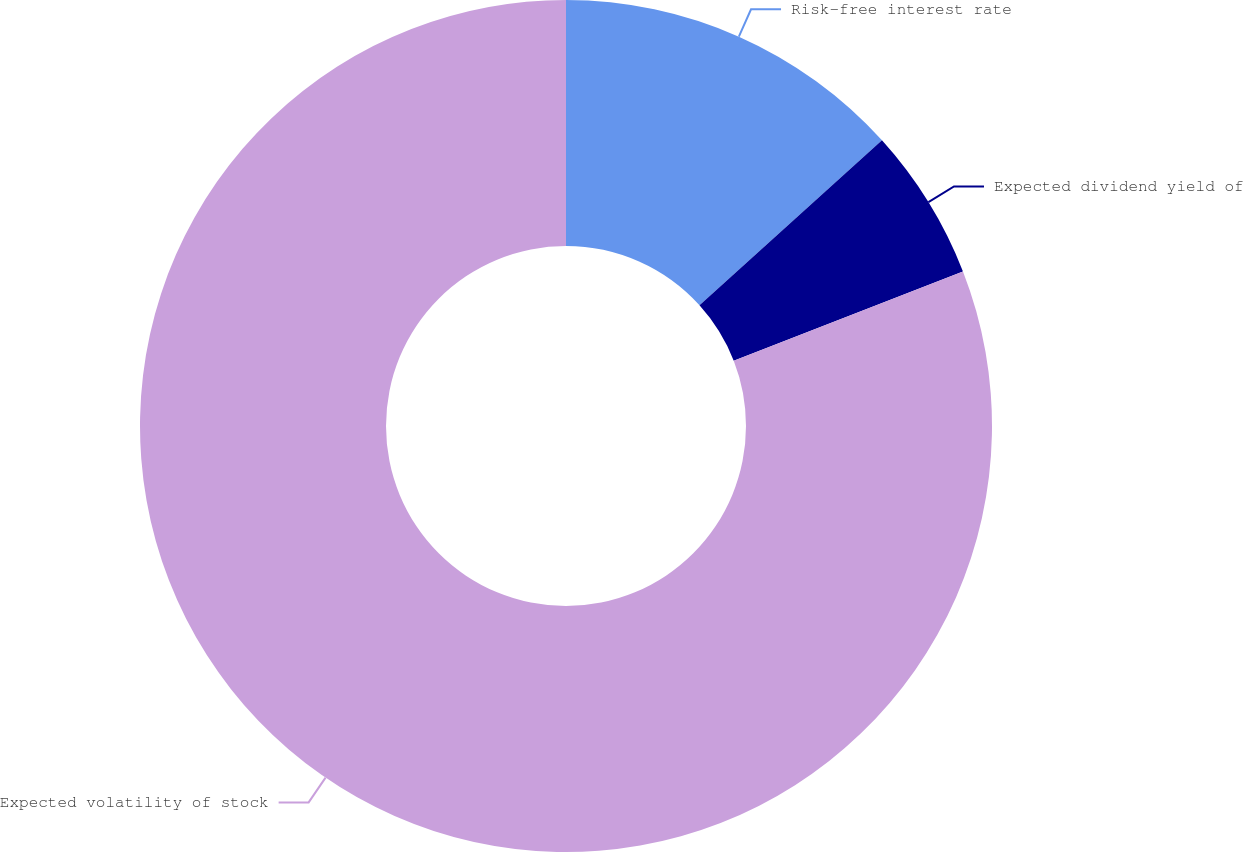Convert chart to OTSL. <chart><loc_0><loc_0><loc_500><loc_500><pie_chart><fcel>Risk-free interest rate<fcel>Expected dividend yield of<fcel>Expected volatility of stock<nl><fcel>13.3%<fcel>5.79%<fcel>80.91%<nl></chart> 